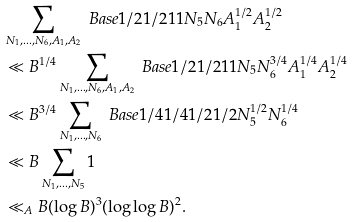<formula> <loc_0><loc_0><loc_500><loc_500>& \sum _ { N _ { 1 } , \dots , N _ { 6 } , A _ { 1 } , A _ { 2 } } \ B a s e { 1 / 2 } { 1 / 2 } 1 1 N _ { 5 } N _ { 6 } A _ { 1 } ^ { 1 / 2 } A _ { 2 } ^ { 1 / 2 } \\ & \ll B ^ { 1 / 4 } \sum _ { N _ { 1 } , \dots , N _ { 6 } , A _ { 1 } , A _ { 2 } } \ B a s e { 1 / 2 } { 1 / 2 } 1 1 N _ { 5 } N _ { 6 } ^ { 3 / 4 } A _ { 1 } ^ { 1 / 4 } A _ { 2 } ^ { 1 / 4 } \\ & \ll B ^ { 3 / 4 } \sum _ { N _ { 1 } , \dots , N _ { 6 } } \ B a s e { 1 / 4 } { 1 / 4 } { 1 / 2 } { 1 / 2 } N _ { 5 } ^ { 1 / 2 } N _ { 6 } ^ { 1 / 4 } \\ & \ll B \sum _ { N _ { 1 } , \dots , N _ { 5 } } 1 \\ & \ll _ { A } B ( \log B ) ^ { 3 } ( \log \log B ) ^ { 2 } .</formula> 